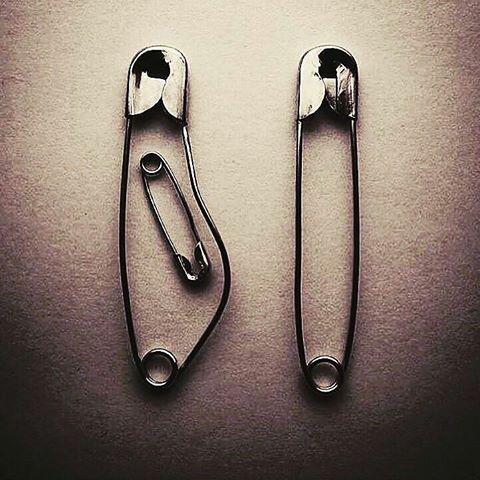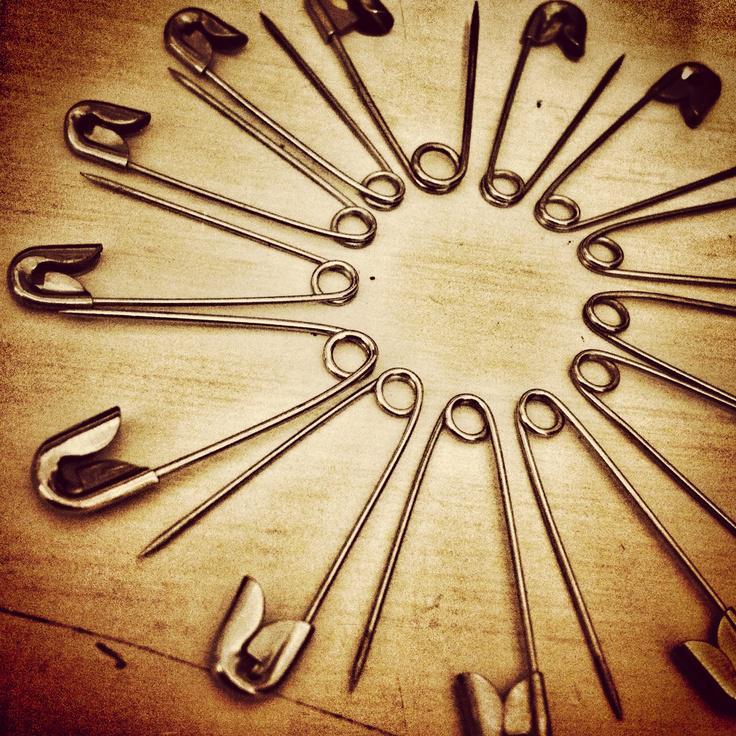The first image is the image on the left, the second image is the image on the right. Assess this claim about the two images: "a bobby pin is bent and sitting on a tiny chair". Correct or not? Answer yes or no. No. The first image is the image on the left, the second image is the image on the right. Examine the images to the left and right. Is the description "One safety pin is open and bent with it' sharp point above another safety pin." accurate? Answer yes or no. No. 